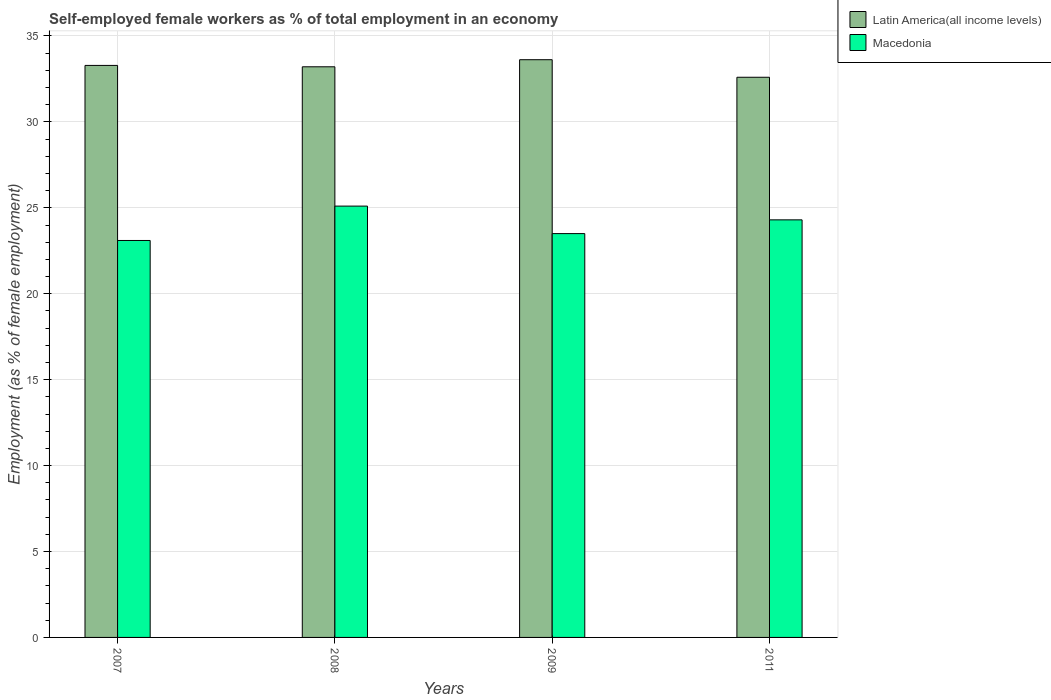How many bars are there on the 3rd tick from the left?
Ensure brevity in your answer.  2. What is the label of the 4th group of bars from the left?
Your answer should be compact. 2011. In how many cases, is the number of bars for a given year not equal to the number of legend labels?
Offer a terse response. 0. What is the percentage of self-employed female workers in Macedonia in 2007?
Your answer should be very brief. 23.1. Across all years, what is the maximum percentage of self-employed female workers in Latin America(all income levels)?
Ensure brevity in your answer.  33.62. Across all years, what is the minimum percentage of self-employed female workers in Macedonia?
Your response must be concise. 23.1. In which year was the percentage of self-employed female workers in Macedonia maximum?
Give a very brief answer. 2008. In which year was the percentage of self-employed female workers in Macedonia minimum?
Your answer should be compact. 2007. What is the total percentage of self-employed female workers in Macedonia in the graph?
Your answer should be very brief. 96. What is the difference between the percentage of self-employed female workers in Latin America(all income levels) in 2007 and that in 2011?
Keep it short and to the point. 0.69. What is the difference between the percentage of self-employed female workers in Macedonia in 2008 and the percentage of self-employed female workers in Latin America(all income levels) in 2009?
Provide a succinct answer. -8.52. What is the average percentage of self-employed female workers in Macedonia per year?
Ensure brevity in your answer.  24. In the year 2007, what is the difference between the percentage of self-employed female workers in Macedonia and percentage of self-employed female workers in Latin America(all income levels)?
Your answer should be compact. -10.19. In how many years, is the percentage of self-employed female workers in Latin America(all income levels) greater than 9 %?
Provide a short and direct response. 4. What is the ratio of the percentage of self-employed female workers in Latin America(all income levels) in 2009 to that in 2011?
Ensure brevity in your answer.  1.03. Is the percentage of self-employed female workers in Latin America(all income levels) in 2007 less than that in 2008?
Provide a succinct answer. No. Is the difference between the percentage of self-employed female workers in Macedonia in 2007 and 2011 greater than the difference between the percentage of self-employed female workers in Latin America(all income levels) in 2007 and 2011?
Your response must be concise. No. What is the difference between the highest and the second highest percentage of self-employed female workers in Latin America(all income levels)?
Your answer should be very brief. 0.33. What is the difference between the highest and the lowest percentage of self-employed female workers in Latin America(all income levels)?
Give a very brief answer. 1.02. In how many years, is the percentage of self-employed female workers in Macedonia greater than the average percentage of self-employed female workers in Macedonia taken over all years?
Your answer should be very brief. 2. What does the 1st bar from the left in 2007 represents?
Ensure brevity in your answer.  Latin America(all income levels). What does the 2nd bar from the right in 2009 represents?
Provide a succinct answer. Latin America(all income levels). How many bars are there?
Keep it short and to the point. 8. Are all the bars in the graph horizontal?
Offer a terse response. No. How many years are there in the graph?
Provide a short and direct response. 4. What is the difference between two consecutive major ticks on the Y-axis?
Keep it short and to the point. 5. Does the graph contain any zero values?
Give a very brief answer. No. Does the graph contain grids?
Provide a succinct answer. Yes. What is the title of the graph?
Offer a very short reply. Self-employed female workers as % of total employment in an economy. Does "Eritrea" appear as one of the legend labels in the graph?
Make the answer very short. No. What is the label or title of the X-axis?
Your response must be concise. Years. What is the label or title of the Y-axis?
Offer a terse response. Employment (as % of female employment). What is the Employment (as % of female employment) of Latin America(all income levels) in 2007?
Your answer should be compact. 33.29. What is the Employment (as % of female employment) of Macedonia in 2007?
Offer a very short reply. 23.1. What is the Employment (as % of female employment) in Latin America(all income levels) in 2008?
Your answer should be compact. 33.21. What is the Employment (as % of female employment) in Macedonia in 2008?
Offer a very short reply. 25.1. What is the Employment (as % of female employment) in Latin America(all income levels) in 2009?
Offer a terse response. 33.62. What is the Employment (as % of female employment) in Macedonia in 2009?
Make the answer very short. 23.5. What is the Employment (as % of female employment) in Latin America(all income levels) in 2011?
Provide a short and direct response. 32.6. What is the Employment (as % of female employment) of Macedonia in 2011?
Keep it short and to the point. 24.3. Across all years, what is the maximum Employment (as % of female employment) in Latin America(all income levels)?
Give a very brief answer. 33.62. Across all years, what is the maximum Employment (as % of female employment) in Macedonia?
Keep it short and to the point. 25.1. Across all years, what is the minimum Employment (as % of female employment) in Latin America(all income levels)?
Offer a terse response. 32.6. Across all years, what is the minimum Employment (as % of female employment) in Macedonia?
Provide a short and direct response. 23.1. What is the total Employment (as % of female employment) in Latin America(all income levels) in the graph?
Keep it short and to the point. 132.71. What is the total Employment (as % of female employment) of Macedonia in the graph?
Your response must be concise. 96. What is the difference between the Employment (as % of female employment) in Latin America(all income levels) in 2007 and that in 2008?
Your response must be concise. 0.08. What is the difference between the Employment (as % of female employment) in Latin America(all income levels) in 2007 and that in 2009?
Keep it short and to the point. -0.33. What is the difference between the Employment (as % of female employment) of Macedonia in 2007 and that in 2009?
Keep it short and to the point. -0.4. What is the difference between the Employment (as % of female employment) in Latin America(all income levels) in 2007 and that in 2011?
Offer a very short reply. 0.69. What is the difference between the Employment (as % of female employment) of Macedonia in 2007 and that in 2011?
Give a very brief answer. -1.2. What is the difference between the Employment (as % of female employment) in Latin America(all income levels) in 2008 and that in 2009?
Make the answer very short. -0.41. What is the difference between the Employment (as % of female employment) in Macedonia in 2008 and that in 2009?
Offer a terse response. 1.6. What is the difference between the Employment (as % of female employment) in Latin America(all income levels) in 2008 and that in 2011?
Your response must be concise. 0.61. What is the difference between the Employment (as % of female employment) of Latin America(all income levels) in 2009 and that in 2011?
Provide a short and direct response. 1.02. What is the difference between the Employment (as % of female employment) of Macedonia in 2009 and that in 2011?
Give a very brief answer. -0.8. What is the difference between the Employment (as % of female employment) in Latin America(all income levels) in 2007 and the Employment (as % of female employment) in Macedonia in 2008?
Ensure brevity in your answer.  8.19. What is the difference between the Employment (as % of female employment) in Latin America(all income levels) in 2007 and the Employment (as % of female employment) in Macedonia in 2009?
Make the answer very short. 9.79. What is the difference between the Employment (as % of female employment) of Latin America(all income levels) in 2007 and the Employment (as % of female employment) of Macedonia in 2011?
Make the answer very short. 8.99. What is the difference between the Employment (as % of female employment) in Latin America(all income levels) in 2008 and the Employment (as % of female employment) in Macedonia in 2009?
Provide a short and direct response. 9.71. What is the difference between the Employment (as % of female employment) in Latin America(all income levels) in 2008 and the Employment (as % of female employment) in Macedonia in 2011?
Your answer should be compact. 8.91. What is the difference between the Employment (as % of female employment) of Latin America(all income levels) in 2009 and the Employment (as % of female employment) of Macedonia in 2011?
Your answer should be compact. 9.32. What is the average Employment (as % of female employment) in Latin America(all income levels) per year?
Provide a succinct answer. 33.18. In the year 2007, what is the difference between the Employment (as % of female employment) of Latin America(all income levels) and Employment (as % of female employment) of Macedonia?
Provide a succinct answer. 10.19. In the year 2008, what is the difference between the Employment (as % of female employment) in Latin America(all income levels) and Employment (as % of female employment) in Macedonia?
Make the answer very short. 8.11. In the year 2009, what is the difference between the Employment (as % of female employment) of Latin America(all income levels) and Employment (as % of female employment) of Macedonia?
Provide a succinct answer. 10.12. In the year 2011, what is the difference between the Employment (as % of female employment) in Latin America(all income levels) and Employment (as % of female employment) in Macedonia?
Provide a short and direct response. 8.3. What is the ratio of the Employment (as % of female employment) in Macedonia in 2007 to that in 2008?
Ensure brevity in your answer.  0.92. What is the ratio of the Employment (as % of female employment) in Latin America(all income levels) in 2007 to that in 2009?
Provide a succinct answer. 0.99. What is the ratio of the Employment (as % of female employment) in Latin America(all income levels) in 2007 to that in 2011?
Your response must be concise. 1.02. What is the ratio of the Employment (as % of female employment) of Macedonia in 2007 to that in 2011?
Give a very brief answer. 0.95. What is the ratio of the Employment (as % of female employment) of Latin America(all income levels) in 2008 to that in 2009?
Your response must be concise. 0.99. What is the ratio of the Employment (as % of female employment) in Macedonia in 2008 to that in 2009?
Your answer should be compact. 1.07. What is the ratio of the Employment (as % of female employment) in Latin America(all income levels) in 2008 to that in 2011?
Your response must be concise. 1.02. What is the ratio of the Employment (as % of female employment) of Macedonia in 2008 to that in 2011?
Your answer should be compact. 1.03. What is the ratio of the Employment (as % of female employment) in Latin America(all income levels) in 2009 to that in 2011?
Your response must be concise. 1.03. What is the ratio of the Employment (as % of female employment) of Macedonia in 2009 to that in 2011?
Offer a terse response. 0.97. What is the difference between the highest and the second highest Employment (as % of female employment) of Latin America(all income levels)?
Your answer should be compact. 0.33. What is the difference between the highest and the second highest Employment (as % of female employment) in Macedonia?
Your answer should be very brief. 0.8. What is the difference between the highest and the lowest Employment (as % of female employment) in Latin America(all income levels)?
Make the answer very short. 1.02. 